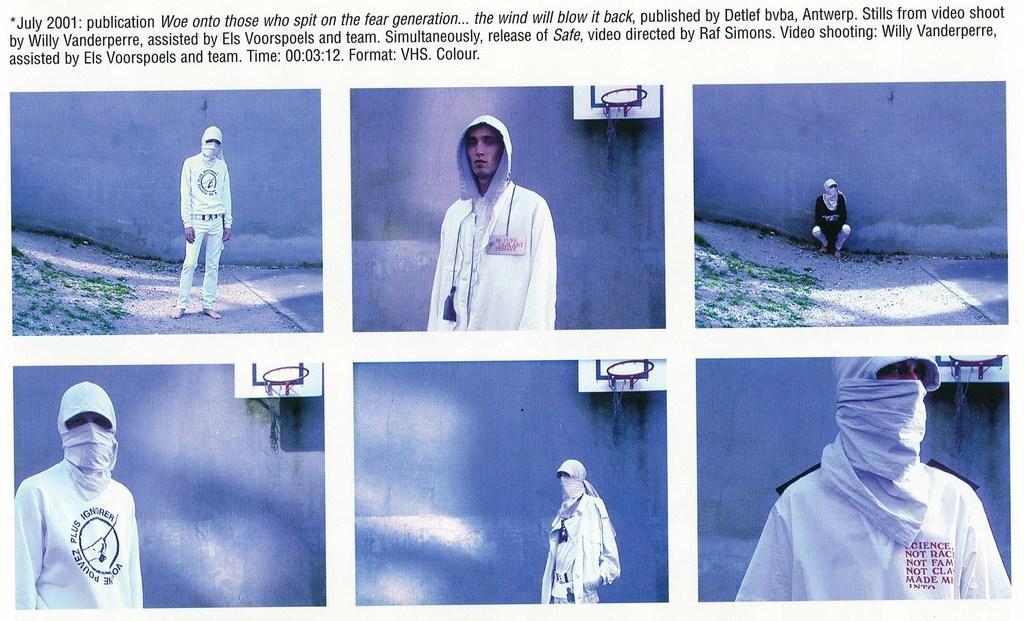How would you summarize this image in a sentence or two? This is a collage picture. I can see a man in different angles, there is a basketball hoop, and in the background there is a wall and there are some words and numbers on the image. 